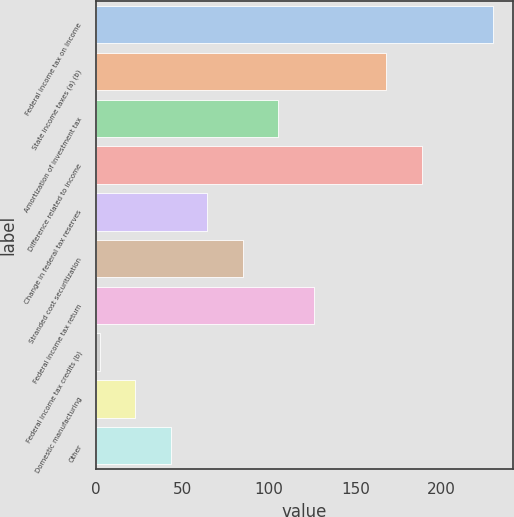Convert chart. <chart><loc_0><loc_0><loc_500><loc_500><bar_chart><fcel>Federal income tax on Income<fcel>State income taxes (a) (b)<fcel>Amortization of investment tax<fcel>Difference related to income<fcel>Change in federal tax reserves<fcel>Stranded cost securitization<fcel>Federal income tax return<fcel>Federal income tax credits (b)<fcel>Domestic manufacturing<fcel>Other<nl><fcel>229.7<fcel>167.6<fcel>105.5<fcel>188.3<fcel>64.1<fcel>84.8<fcel>126.2<fcel>2<fcel>22.7<fcel>43.4<nl></chart> 